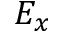<formula> <loc_0><loc_0><loc_500><loc_500>E _ { x }</formula> 